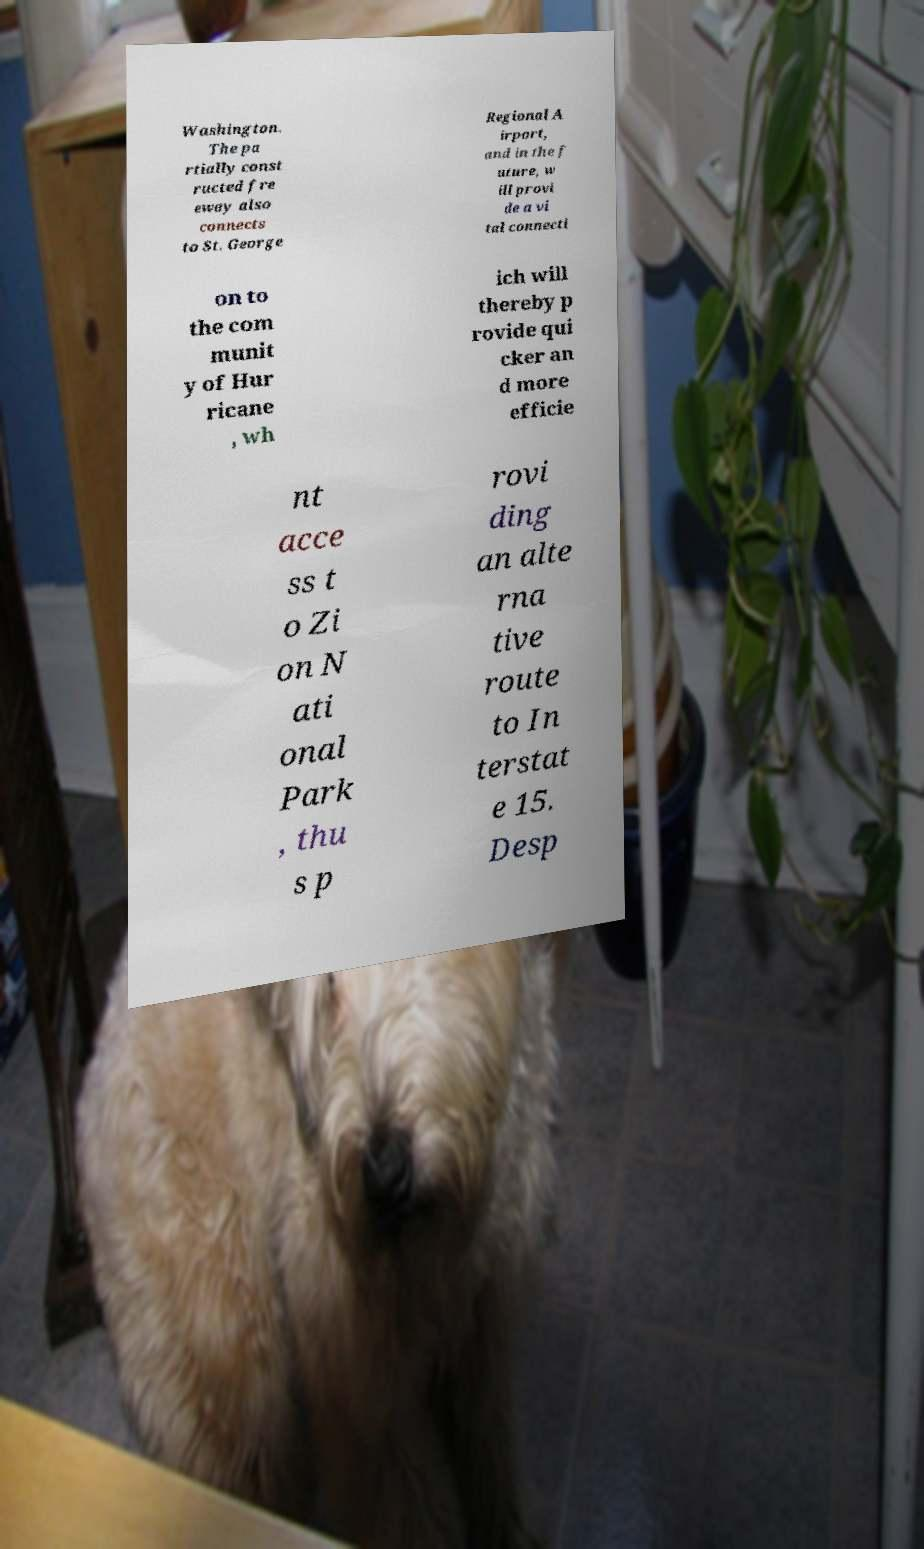Please identify and transcribe the text found in this image. Washington. The pa rtially const ructed fre eway also connects to St. George Regional A irport, and in the f uture, w ill provi de a vi tal connecti on to the com munit y of Hur ricane , wh ich will thereby p rovide qui cker an d more efficie nt acce ss t o Zi on N ati onal Park , thu s p rovi ding an alte rna tive route to In terstat e 15. Desp 